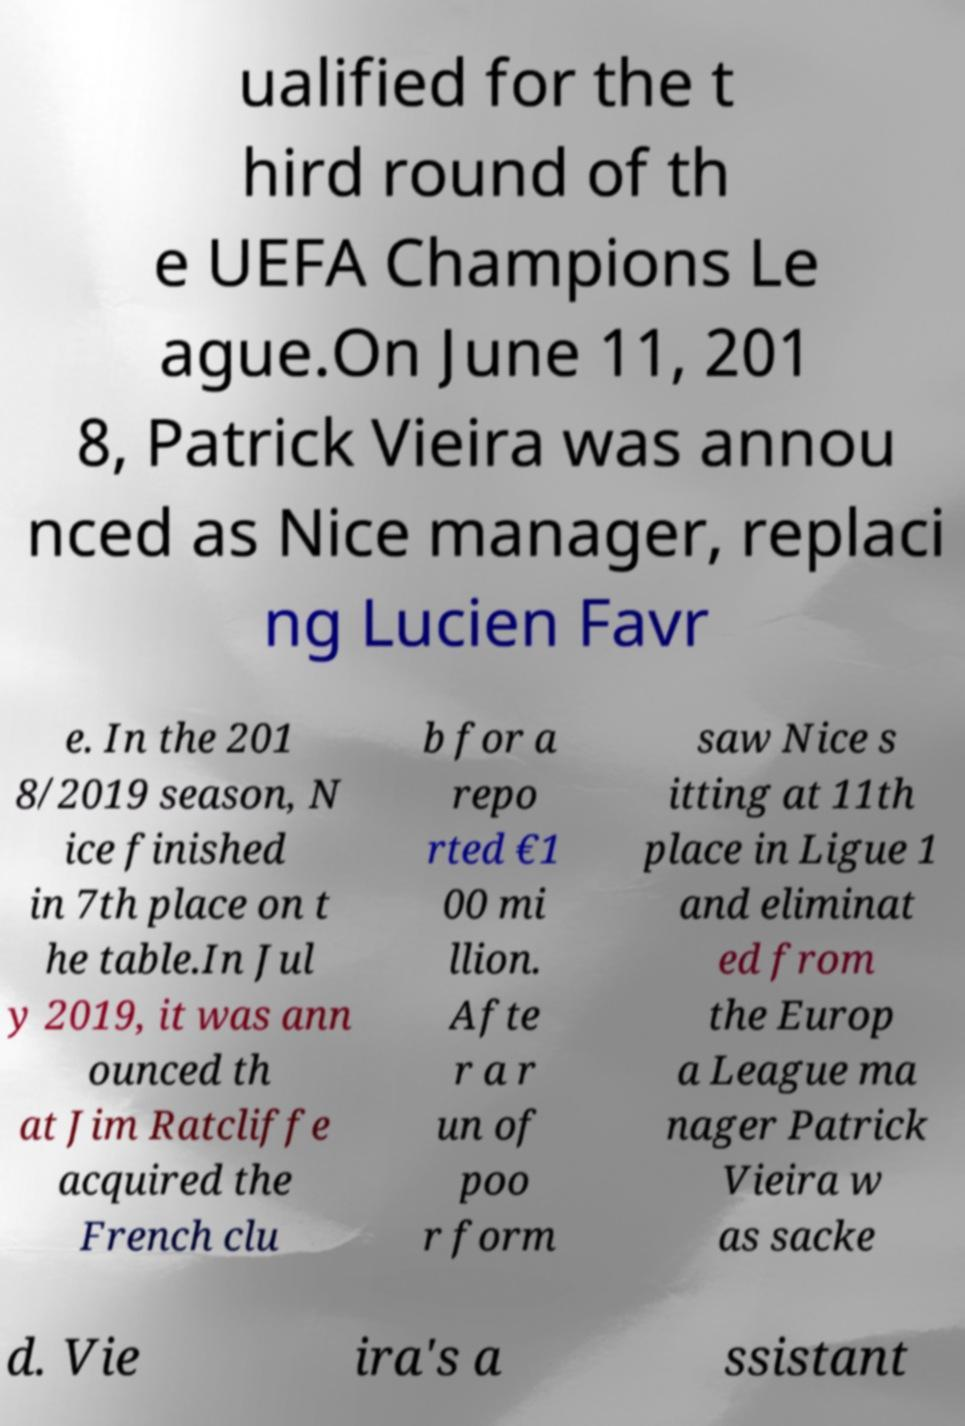Can you accurately transcribe the text from the provided image for me? ualified for the t hird round of th e UEFA Champions Le ague.On June 11, 201 8, Patrick Vieira was annou nced as Nice manager, replaci ng Lucien Favr e. In the 201 8/2019 season, N ice finished in 7th place on t he table.In Jul y 2019, it was ann ounced th at Jim Ratcliffe acquired the French clu b for a repo rted €1 00 mi llion. Afte r a r un of poo r form saw Nice s itting at 11th place in Ligue 1 and eliminat ed from the Europ a League ma nager Patrick Vieira w as sacke d. Vie ira's a ssistant 